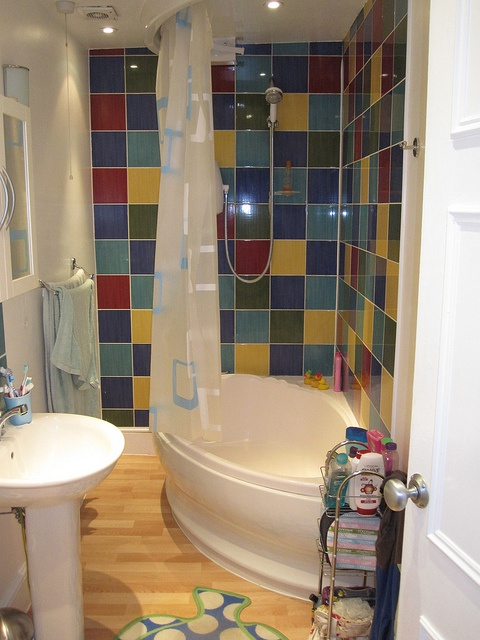Describe the objects in this image and their specific colors. I can see sink in gray, ivory, and tan tones, bottle in gray, darkgray, and maroon tones, cup in gray, darkgray, and lightblue tones, bottle in gray, brown, and purple tones, and toothbrush in gray, darkgray, and tan tones in this image. 